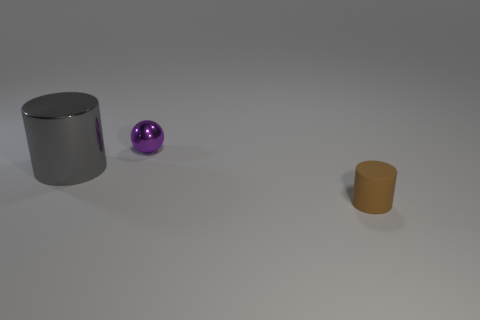Are there any other things that have the same size as the metal ball?
Keep it short and to the point. Yes. The small thing that is the same material as the gray cylinder is what color?
Provide a succinct answer. Purple. How big is the thing that is behind the small brown rubber object and on the right side of the large gray object?
Your answer should be compact. Small. Are there fewer tiny things in front of the large metal cylinder than metallic things that are right of the purple ball?
Give a very brief answer. No. Do the cylinder in front of the large gray cylinder and the cylinder that is on the left side of the small purple object have the same material?
Ensure brevity in your answer.  No. There is a thing that is both behind the brown rubber object and to the right of the large gray object; what is its shape?
Offer a terse response. Sphere. What material is the small thing on the right side of the small thing behind the matte thing made of?
Keep it short and to the point. Rubber. Are there more tiny brown rubber spheres than small brown rubber cylinders?
Your answer should be very brief. No. What is the material of the cylinder that is the same size as the purple ball?
Give a very brief answer. Rubber. Does the tiny sphere have the same material as the small brown cylinder?
Give a very brief answer. No. 